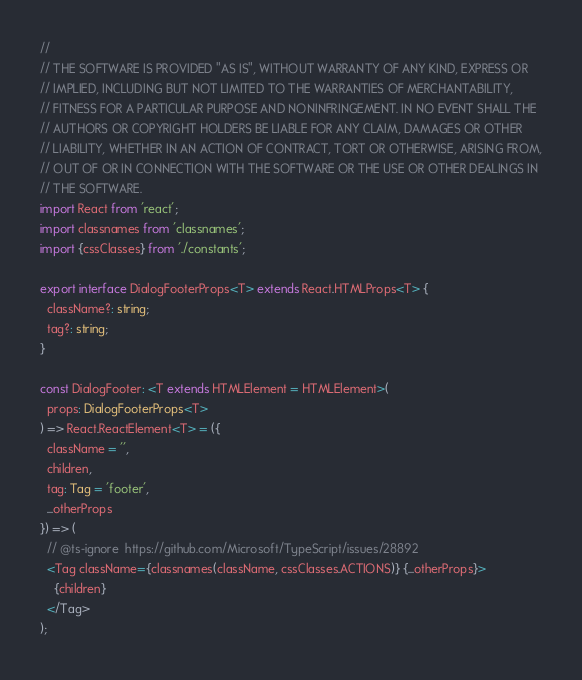<code> <loc_0><loc_0><loc_500><loc_500><_TypeScript_>//
// THE SOFTWARE IS PROVIDED "AS IS", WITHOUT WARRANTY OF ANY KIND, EXPRESS OR
// IMPLIED, INCLUDING BUT NOT LIMITED TO THE WARRANTIES OF MERCHANTABILITY,
// FITNESS FOR A PARTICULAR PURPOSE AND NONINFRINGEMENT. IN NO EVENT SHALL THE
// AUTHORS OR COPYRIGHT HOLDERS BE LIABLE FOR ANY CLAIM, DAMAGES OR OTHER
// LIABILITY, WHETHER IN AN ACTION OF CONTRACT, TORT OR OTHERWISE, ARISING FROM,
// OUT OF OR IN CONNECTION WITH THE SOFTWARE OR THE USE OR OTHER DEALINGS IN
// THE SOFTWARE.
import React from 'react';
import classnames from 'classnames';
import {cssClasses} from './constants';

export interface DialogFooterProps<T> extends React.HTMLProps<T> {
  className?: string;
  tag?: string;
}

const DialogFooter: <T extends HTMLElement = HTMLElement>(
  props: DialogFooterProps<T>
) => React.ReactElement<T> = ({
  className = '',
  children,
  tag: Tag = 'footer',
  ...otherProps
}) => (
  // @ts-ignore  https://github.com/Microsoft/TypeScript/issues/28892
  <Tag className={classnames(className, cssClasses.ACTIONS)} {...otherProps}>
    {children}
  </Tag>
);
</code> 